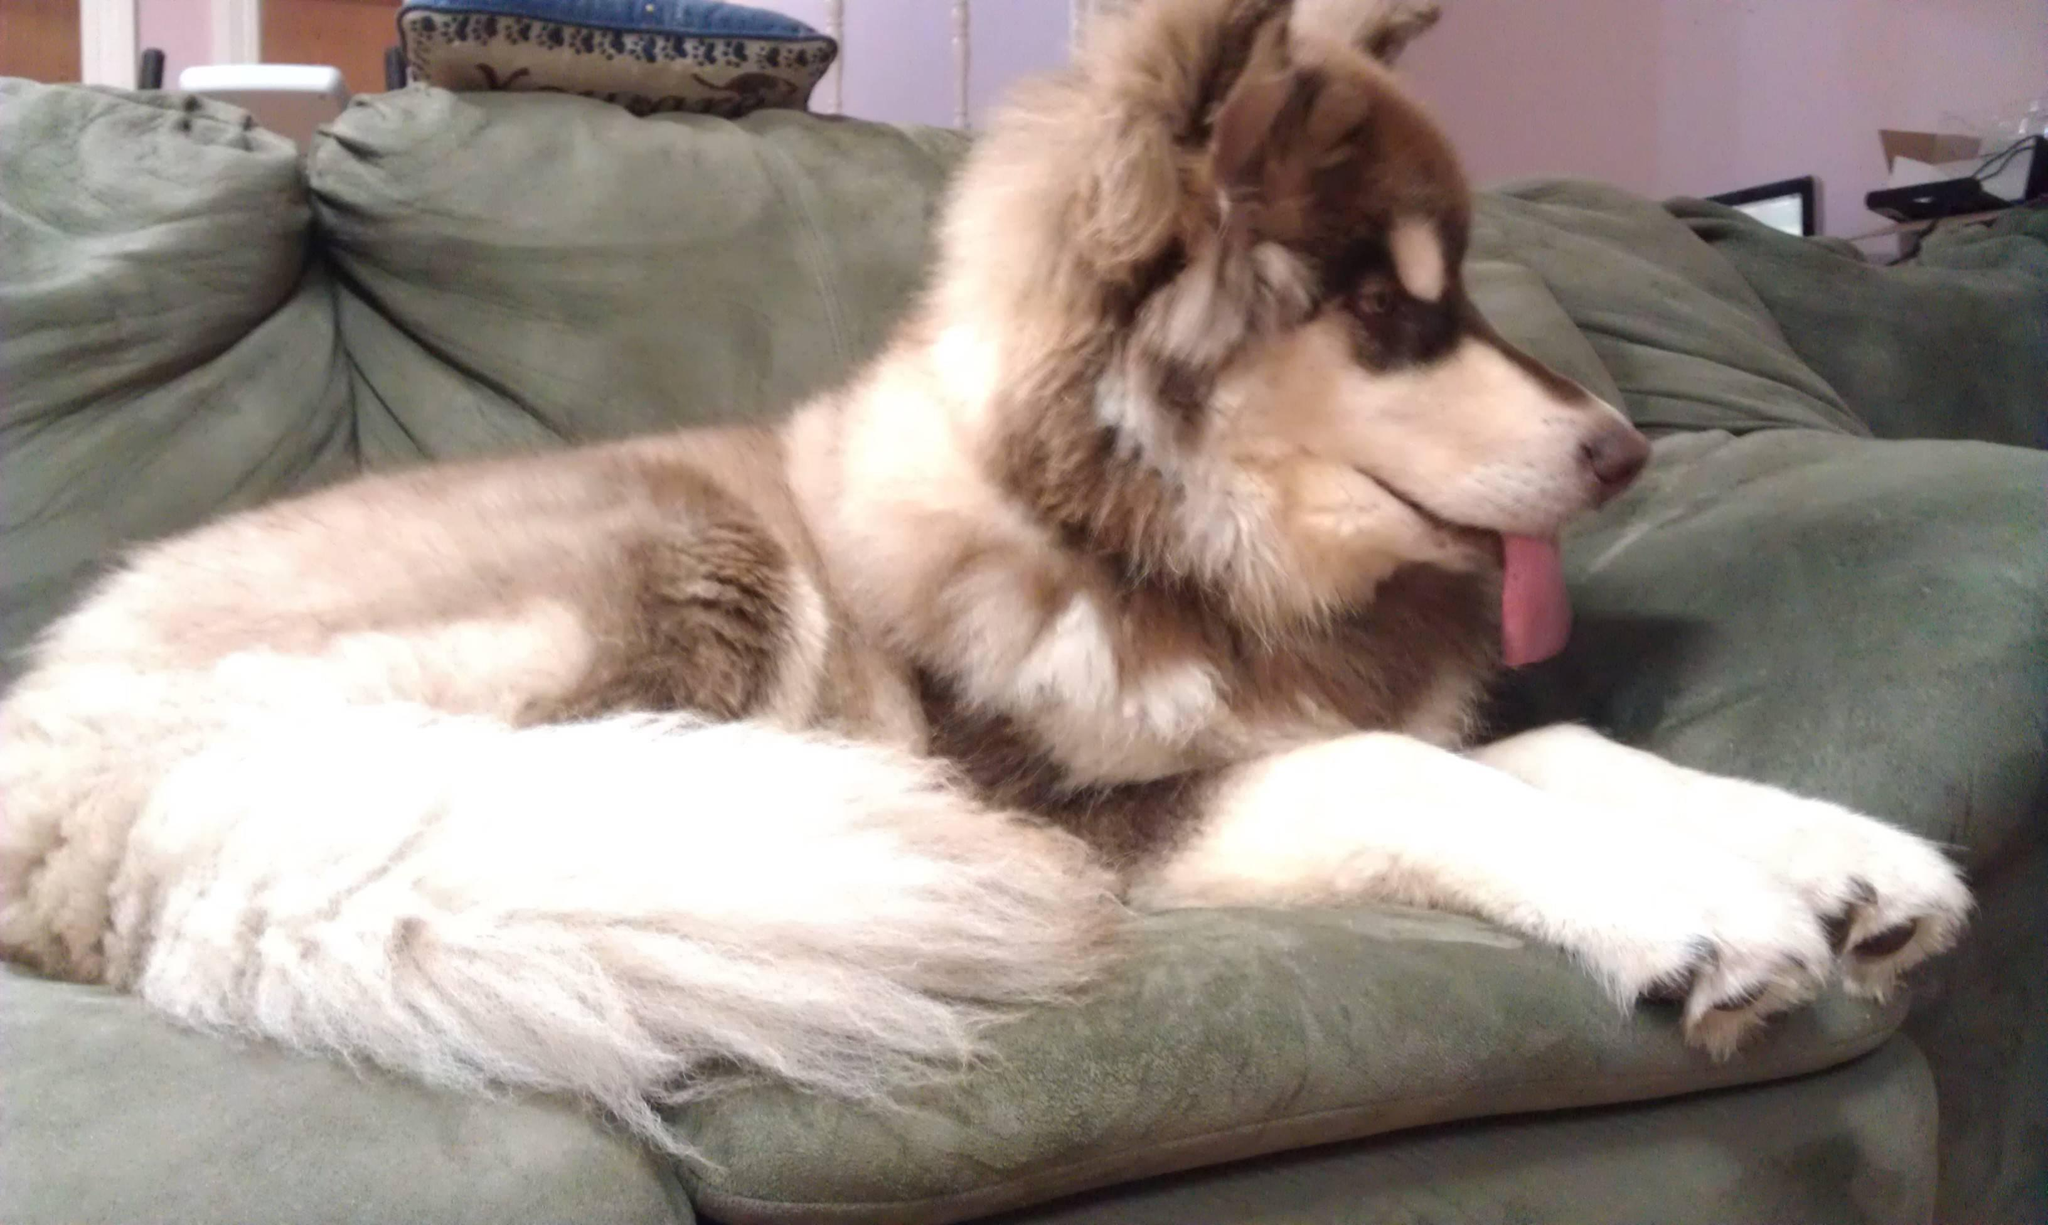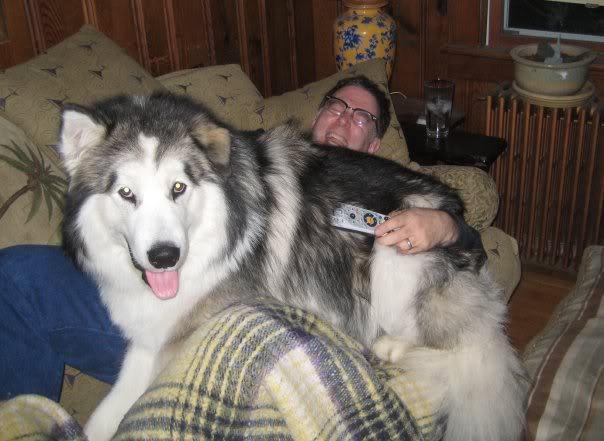The first image is the image on the left, the second image is the image on the right. Considering the images on both sides, is "The left image shows a dog in some kind of reclining pose on a sofa, and the right image includes a husky dog outdoors on snow-covered ground." valid? Answer yes or no. No. The first image is the image on the left, the second image is the image on the right. Given the left and right images, does the statement "There are two dogs outside." hold true? Answer yes or no. No. 